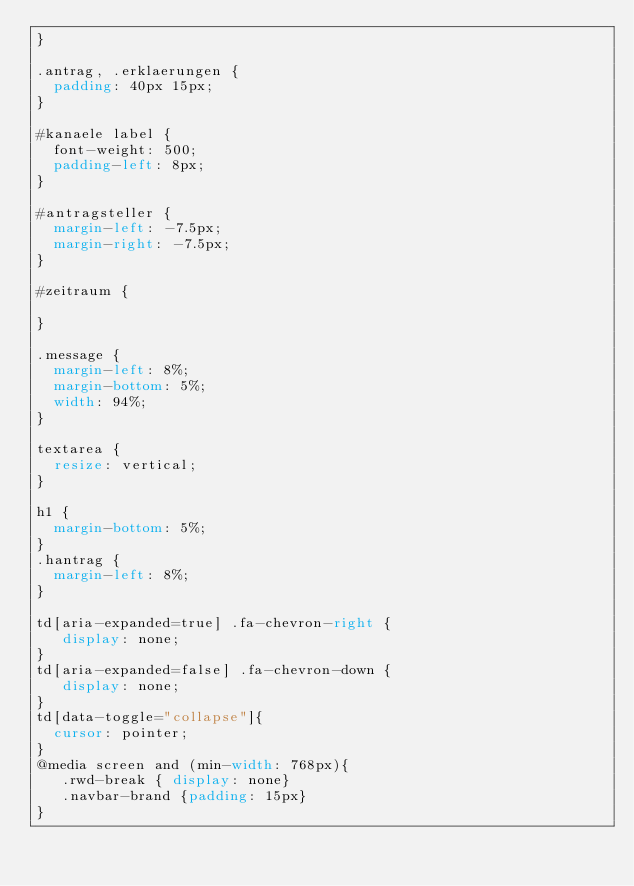<code> <loc_0><loc_0><loc_500><loc_500><_CSS_>}

.antrag, .erklaerungen {
  padding: 40px 15px;
}

#kanaele label {
  font-weight: 500;
  padding-left: 8px;
}

#antragsteller {
  margin-left: -7.5px;
  margin-right: -7.5px;
}

#zeitraum {

}

.message {
  margin-left: 8%;
  margin-bottom: 5%;
  width: 94%;
}

textarea {
  resize: vertical;
}

h1 {
  margin-bottom: 5%;
}
.hantrag {
  margin-left: 8%;
}

td[aria-expanded=true] .fa-chevron-right {
   display: none;
}
td[aria-expanded=false] .fa-chevron-down {
   display: none;
}
td[data-toggle="collapse"]{
  cursor: pointer;
}
@media screen and (min-width: 768px){
   .rwd-break { display: none}
   .navbar-brand {padding: 15px}
}
</code> 